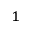Convert formula to latex. <formula><loc_0><loc_0><loc_500><loc_500>^ { 1 }</formula> 